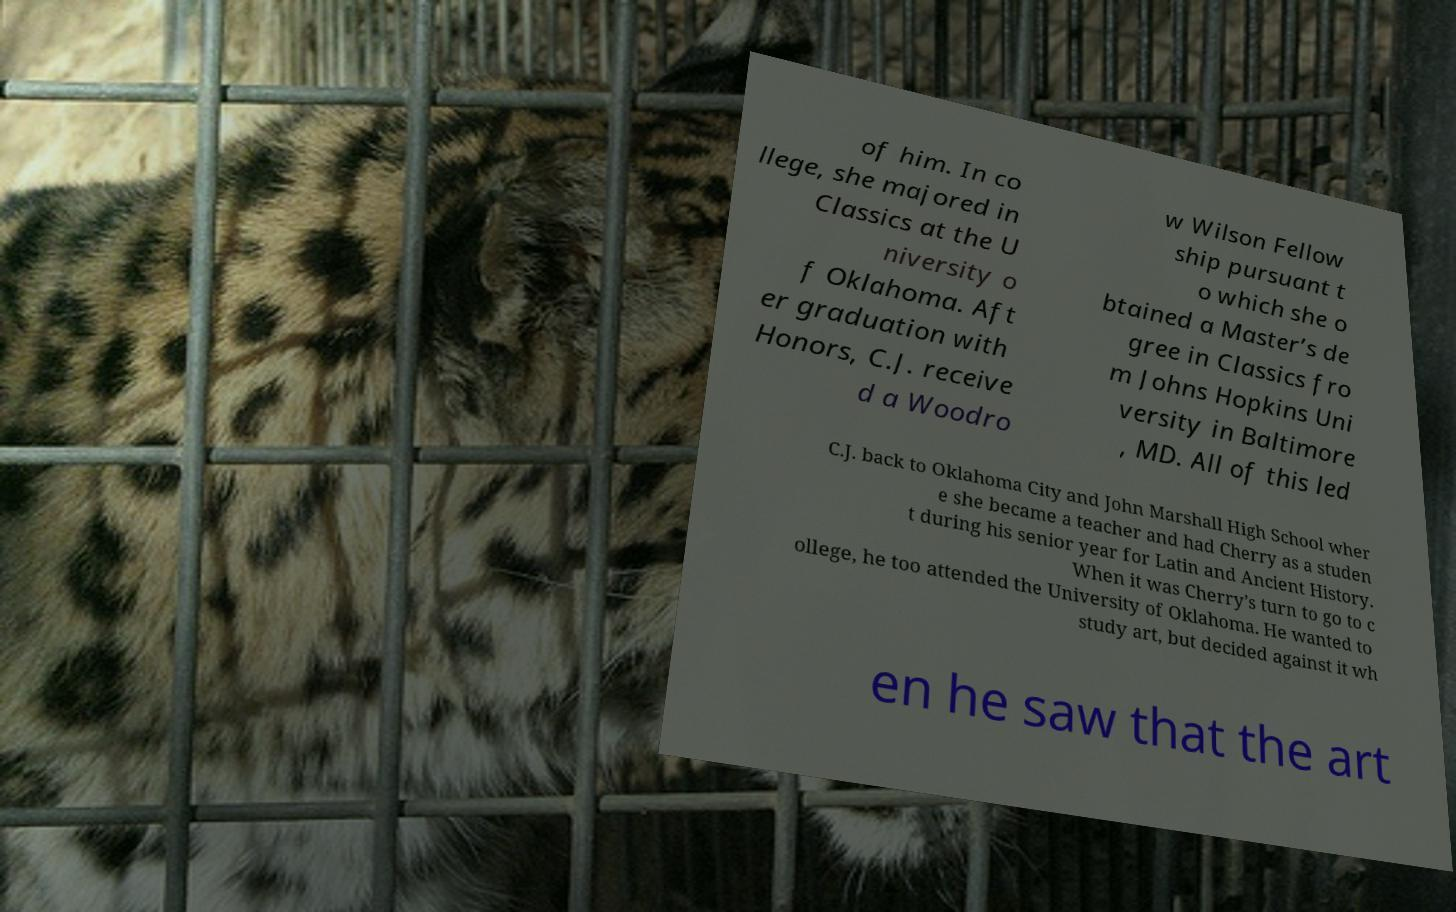Please identify and transcribe the text found in this image. of him. In co llege, she majored in Classics at the U niversity o f Oklahoma. Aft er graduation with Honors, C.J. receive d a Woodro w Wilson Fellow ship pursuant t o which she o btained a Master’s de gree in Classics fro m Johns Hopkins Uni versity in Baltimore , MD. All of this led C.J. back to Oklahoma City and John Marshall High School wher e she became a teacher and had Cherry as a studen t during his senior year for Latin and Ancient History. When it was Cherry’s turn to go to c ollege, he too attended the University of Oklahoma. He wanted to study art, but decided against it wh en he saw that the art 